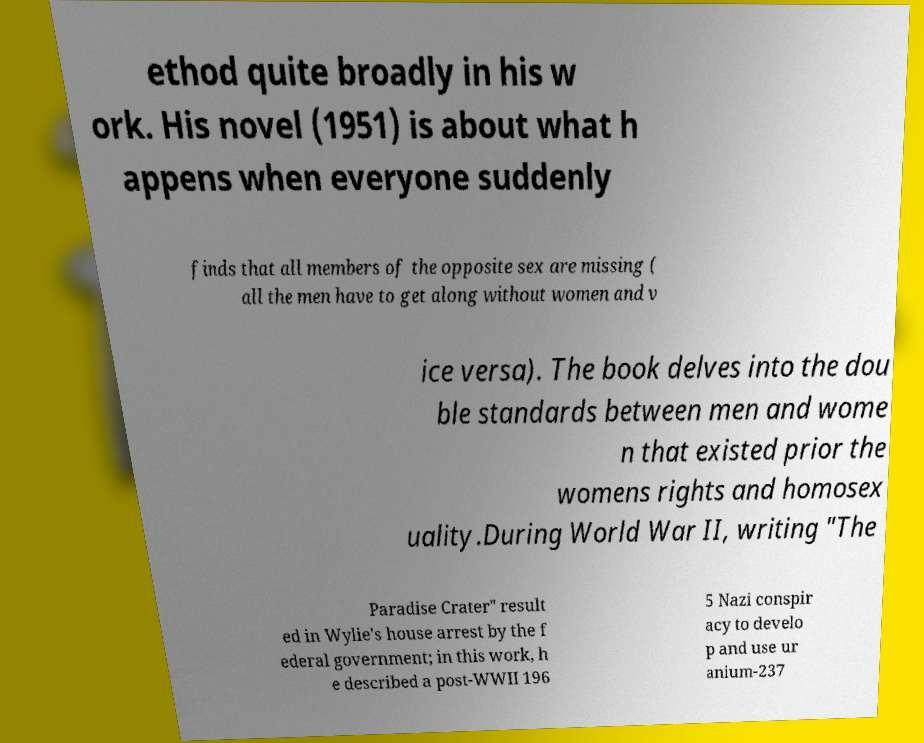Could you extract and type out the text from this image? ethod quite broadly in his w ork. His novel (1951) is about what h appens when everyone suddenly finds that all members of the opposite sex are missing ( all the men have to get along without women and v ice versa). The book delves into the dou ble standards between men and wome n that existed prior the womens rights and homosex uality.During World War II, writing "The Paradise Crater" result ed in Wylie's house arrest by the f ederal government; in this work, h e described a post-WWII 196 5 Nazi conspir acy to develo p and use ur anium-237 